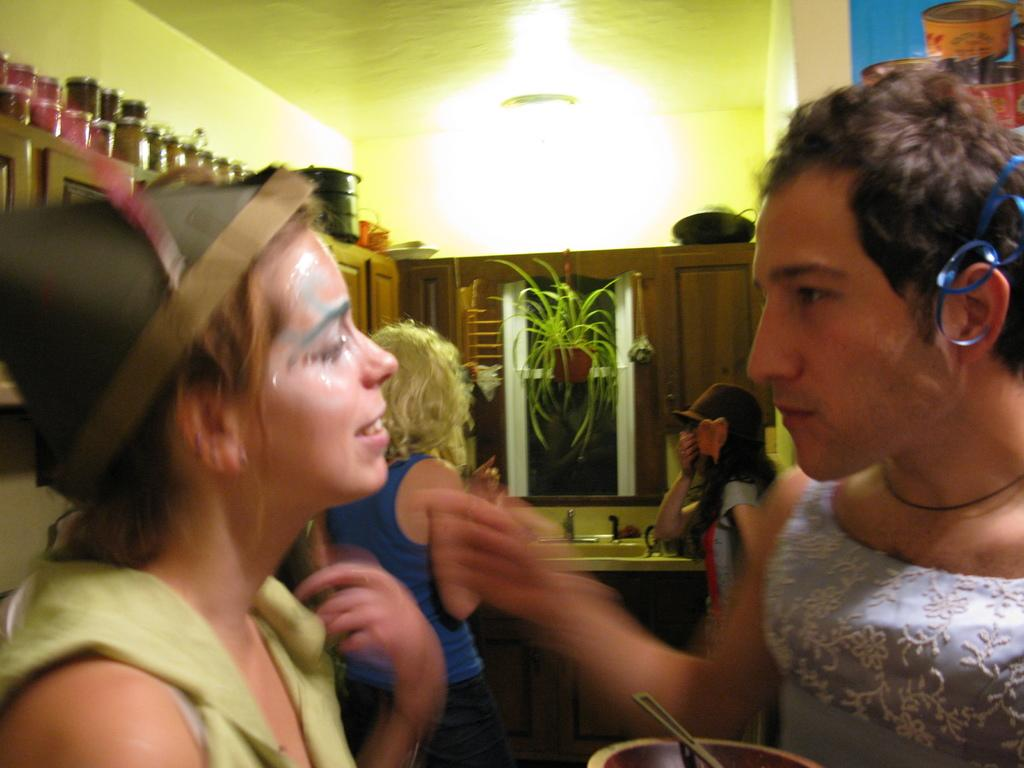How many people are present in the image? There are four people in the image. What type of plant can be seen in the image? There is a houseplant in the image. What is the primary feature of the sink in the image? There is a tap in the image, which is a part of the sink. What type of storage is present in the image? There are cupboards in the image. What type of containers can be seen in the image? There are jars in the image. What is the uppermost part of the room visible in the image? There is a ceiling in the image. What type of decoration is present on the wall in the image? There is a poster in the image. What type of structure surrounds the room in the image? There are walls in the image. What type of objects can be seen in the image? There are some objects in the image. How many trucks are parked in front of the house in the image? There is no information about trucks in the image; it only mentions a houseplant, sink, tap, cupboards, jars, ceiling, poster, and walls. Is there a rifle hanging on the wall in the image? No, there is no rifle present in the image. What type of mineral can be seen on the floor in the image? There is no mention of any mineral, specifically quartz, in the image. 